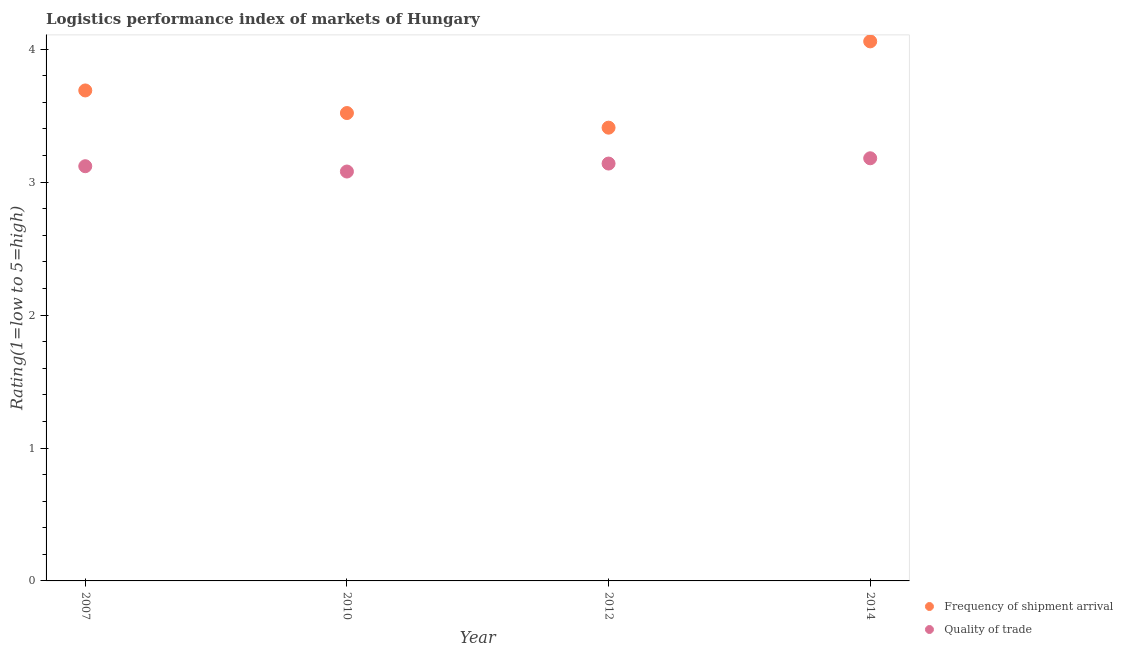How many different coloured dotlines are there?
Provide a succinct answer. 2. What is the lpi quality of trade in 2012?
Provide a succinct answer. 3.14. Across all years, what is the maximum lpi quality of trade?
Ensure brevity in your answer.  3.18. Across all years, what is the minimum lpi quality of trade?
Your answer should be very brief. 3.08. In which year was the lpi of frequency of shipment arrival maximum?
Keep it short and to the point. 2014. What is the total lpi of frequency of shipment arrival in the graph?
Make the answer very short. 14.68. What is the difference between the lpi quality of trade in 2010 and that in 2012?
Make the answer very short. -0.06. What is the difference between the lpi quality of trade in 2010 and the lpi of frequency of shipment arrival in 2012?
Offer a very short reply. -0.33. What is the average lpi quality of trade per year?
Ensure brevity in your answer.  3.13. In the year 2007, what is the difference between the lpi quality of trade and lpi of frequency of shipment arrival?
Make the answer very short. -0.57. In how many years, is the lpi quality of trade greater than 3.2?
Keep it short and to the point. 0. What is the ratio of the lpi of frequency of shipment arrival in 2012 to that in 2014?
Your response must be concise. 0.84. Is the lpi quality of trade in 2010 less than that in 2012?
Offer a very short reply. Yes. Is the difference between the lpi of frequency of shipment arrival in 2007 and 2012 greater than the difference between the lpi quality of trade in 2007 and 2012?
Your answer should be very brief. Yes. What is the difference between the highest and the second highest lpi quality of trade?
Offer a very short reply. 0.04. What is the difference between the highest and the lowest lpi quality of trade?
Give a very brief answer. 0.1. Does the lpi quality of trade monotonically increase over the years?
Keep it short and to the point. No. Is the lpi quality of trade strictly greater than the lpi of frequency of shipment arrival over the years?
Offer a terse response. No. Is the lpi of frequency of shipment arrival strictly less than the lpi quality of trade over the years?
Your response must be concise. No. How many dotlines are there?
Your answer should be compact. 2. Are the values on the major ticks of Y-axis written in scientific E-notation?
Provide a short and direct response. No. Does the graph contain any zero values?
Offer a terse response. No. How many legend labels are there?
Provide a short and direct response. 2. What is the title of the graph?
Make the answer very short. Logistics performance index of markets of Hungary. Does "State government" appear as one of the legend labels in the graph?
Offer a terse response. No. What is the label or title of the Y-axis?
Offer a very short reply. Rating(1=low to 5=high). What is the Rating(1=low to 5=high) of Frequency of shipment arrival in 2007?
Make the answer very short. 3.69. What is the Rating(1=low to 5=high) of Quality of trade in 2007?
Keep it short and to the point. 3.12. What is the Rating(1=low to 5=high) of Frequency of shipment arrival in 2010?
Your answer should be very brief. 3.52. What is the Rating(1=low to 5=high) in Quality of trade in 2010?
Provide a short and direct response. 3.08. What is the Rating(1=low to 5=high) in Frequency of shipment arrival in 2012?
Your answer should be compact. 3.41. What is the Rating(1=low to 5=high) in Quality of trade in 2012?
Make the answer very short. 3.14. What is the Rating(1=low to 5=high) in Frequency of shipment arrival in 2014?
Keep it short and to the point. 4.06. What is the Rating(1=low to 5=high) of Quality of trade in 2014?
Offer a terse response. 3.18. Across all years, what is the maximum Rating(1=low to 5=high) of Frequency of shipment arrival?
Ensure brevity in your answer.  4.06. Across all years, what is the maximum Rating(1=low to 5=high) of Quality of trade?
Ensure brevity in your answer.  3.18. Across all years, what is the minimum Rating(1=low to 5=high) in Frequency of shipment arrival?
Provide a succinct answer. 3.41. Across all years, what is the minimum Rating(1=low to 5=high) of Quality of trade?
Provide a succinct answer. 3.08. What is the total Rating(1=low to 5=high) of Frequency of shipment arrival in the graph?
Offer a very short reply. 14.68. What is the total Rating(1=low to 5=high) of Quality of trade in the graph?
Offer a terse response. 12.52. What is the difference between the Rating(1=low to 5=high) in Frequency of shipment arrival in 2007 and that in 2010?
Keep it short and to the point. 0.17. What is the difference between the Rating(1=low to 5=high) of Quality of trade in 2007 and that in 2010?
Offer a terse response. 0.04. What is the difference between the Rating(1=low to 5=high) of Frequency of shipment arrival in 2007 and that in 2012?
Offer a terse response. 0.28. What is the difference between the Rating(1=low to 5=high) in Quality of trade in 2007 and that in 2012?
Your answer should be compact. -0.02. What is the difference between the Rating(1=low to 5=high) in Frequency of shipment arrival in 2007 and that in 2014?
Offer a terse response. -0.37. What is the difference between the Rating(1=low to 5=high) of Quality of trade in 2007 and that in 2014?
Your answer should be very brief. -0.06. What is the difference between the Rating(1=low to 5=high) of Frequency of shipment arrival in 2010 and that in 2012?
Provide a short and direct response. 0.11. What is the difference between the Rating(1=low to 5=high) of Quality of trade in 2010 and that in 2012?
Your response must be concise. -0.06. What is the difference between the Rating(1=low to 5=high) in Frequency of shipment arrival in 2010 and that in 2014?
Your answer should be very brief. -0.54. What is the difference between the Rating(1=low to 5=high) in Quality of trade in 2010 and that in 2014?
Provide a succinct answer. -0.1. What is the difference between the Rating(1=low to 5=high) of Frequency of shipment arrival in 2012 and that in 2014?
Offer a terse response. -0.65. What is the difference between the Rating(1=low to 5=high) of Quality of trade in 2012 and that in 2014?
Provide a succinct answer. -0.04. What is the difference between the Rating(1=low to 5=high) in Frequency of shipment arrival in 2007 and the Rating(1=low to 5=high) in Quality of trade in 2010?
Give a very brief answer. 0.61. What is the difference between the Rating(1=low to 5=high) of Frequency of shipment arrival in 2007 and the Rating(1=low to 5=high) of Quality of trade in 2012?
Give a very brief answer. 0.55. What is the difference between the Rating(1=low to 5=high) in Frequency of shipment arrival in 2007 and the Rating(1=low to 5=high) in Quality of trade in 2014?
Provide a succinct answer. 0.51. What is the difference between the Rating(1=low to 5=high) in Frequency of shipment arrival in 2010 and the Rating(1=low to 5=high) in Quality of trade in 2012?
Keep it short and to the point. 0.38. What is the difference between the Rating(1=low to 5=high) in Frequency of shipment arrival in 2010 and the Rating(1=low to 5=high) in Quality of trade in 2014?
Offer a very short reply. 0.34. What is the difference between the Rating(1=low to 5=high) of Frequency of shipment arrival in 2012 and the Rating(1=low to 5=high) of Quality of trade in 2014?
Your response must be concise. 0.23. What is the average Rating(1=low to 5=high) in Frequency of shipment arrival per year?
Offer a very short reply. 3.67. What is the average Rating(1=low to 5=high) in Quality of trade per year?
Your answer should be very brief. 3.13. In the year 2007, what is the difference between the Rating(1=low to 5=high) of Frequency of shipment arrival and Rating(1=low to 5=high) of Quality of trade?
Your answer should be compact. 0.57. In the year 2010, what is the difference between the Rating(1=low to 5=high) of Frequency of shipment arrival and Rating(1=low to 5=high) of Quality of trade?
Ensure brevity in your answer.  0.44. In the year 2012, what is the difference between the Rating(1=low to 5=high) of Frequency of shipment arrival and Rating(1=low to 5=high) of Quality of trade?
Give a very brief answer. 0.27. In the year 2014, what is the difference between the Rating(1=low to 5=high) in Frequency of shipment arrival and Rating(1=low to 5=high) in Quality of trade?
Ensure brevity in your answer.  0.88. What is the ratio of the Rating(1=low to 5=high) in Frequency of shipment arrival in 2007 to that in 2010?
Provide a succinct answer. 1.05. What is the ratio of the Rating(1=low to 5=high) of Quality of trade in 2007 to that in 2010?
Give a very brief answer. 1.01. What is the ratio of the Rating(1=low to 5=high) in Frequency of shipment arrival in 2007 to that in 2012?
Your response must be concise. 1.08. What is the ratio of the Rating(1=low to 5=high) of Quality of trade in 2007 to that in 2014?
Your answer should be compact. 0.98. What is the ratio of the Rating(1=low to 5=high) of Frequency of shipment arrival in 2010 to that in 2012?
Your answer should be very brief. 1.03. What is the ratio of the Rating(1=low to 5=high) of Quality of trade in 2010 to that in 2012?
Your answer should be very brief. 0.98. What is the ratio of the Rating(1=low to 5=high) in Frequency of shipment arrival in 2010 to that in 2014?
Keep it short and to the point. 0.87. What is the ratio of the Rating(1=low to 5=high) in Quality of trade in 2010 to that in 2014?
Give a very brief answer. 0.97. What is the ratio of the Rating(1=low to 5=high) of Frequency of shipment arrival in 2012 to that in 2014?
Make the answer very short. 0.84. What is the ratio of the Rating(1=low to 5=high) of Quality of trade in 2012 to that in 2014?
Give a very brief answer. 0.99. What is the difference between the highest and the second highest Rating(1=low to 5=high) of Frequency of shipment arrival?
Keep it short and to the point. 0.37. What is the difference between the highest and the second highest Rating(1=low to 5=high) in Quality of trade?
Ensure brevity in your answer.  0.04. What is the difference between the highest and the lowest Rating(1=low to 5=high) of Frequency of shipment arrival?
Make the answer very short. 0.65. What is the difference between the highest and the lowest Rating(1=low to 5=high) of Quality of trade?
Make the answer very short. 0.1. 